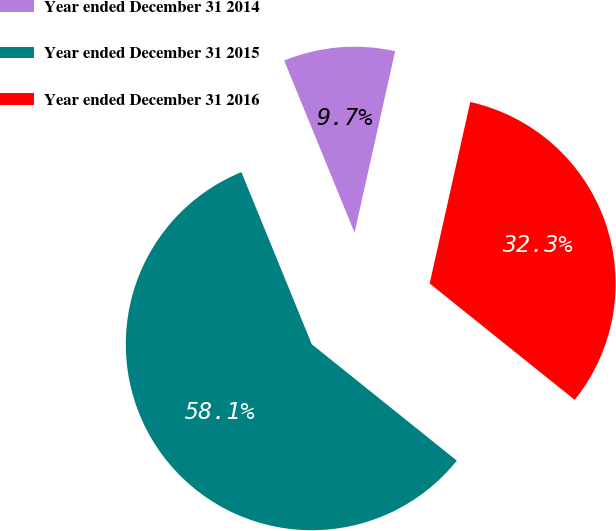<chart> <loc_0><loc_0><loc_500><loc_500><pie_chart><fcel>Year ended December 31 2014<fcel>Year ended December 31 2015<fcel>Year ended December 31 2016<nl><fcel>9.68%<fcel>58.06%<fcel>32.26%<nl></chart> 